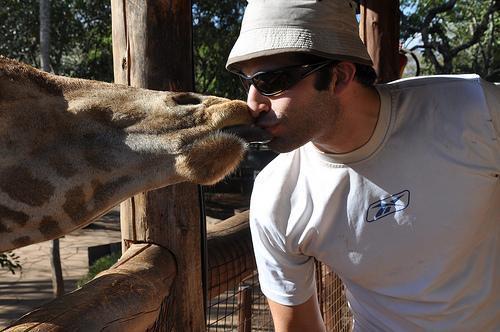How many giraffes are in this photo?
Give a very brief answer. 1. 